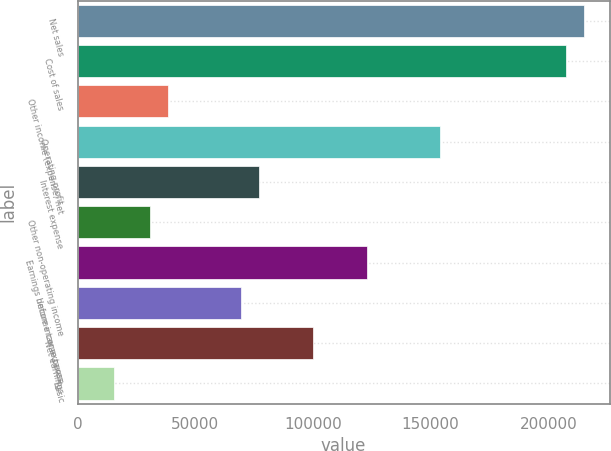Convert chart. <chart><loc_0><loc_0><loc_500><loc_500><bar_chart><fcel>Net sales<fcel>Cost of sales<fcel>Other income (expense) net<fcel>Operating profit<fcel>Interest expense<fcel>Other non-operating income<fcel>Earnings before income taxes<fcel>Income tax expense<fcel>Net earnings<fcel>Basic<nl><fcel>215316<fcel>207626<fcel>38449.8<fcel>153797<fcel>76899<fcel>30759.9<fcel>123038<fcel>69209.1<fcel>99968.5<fcel>15380.3<nl></chart> 